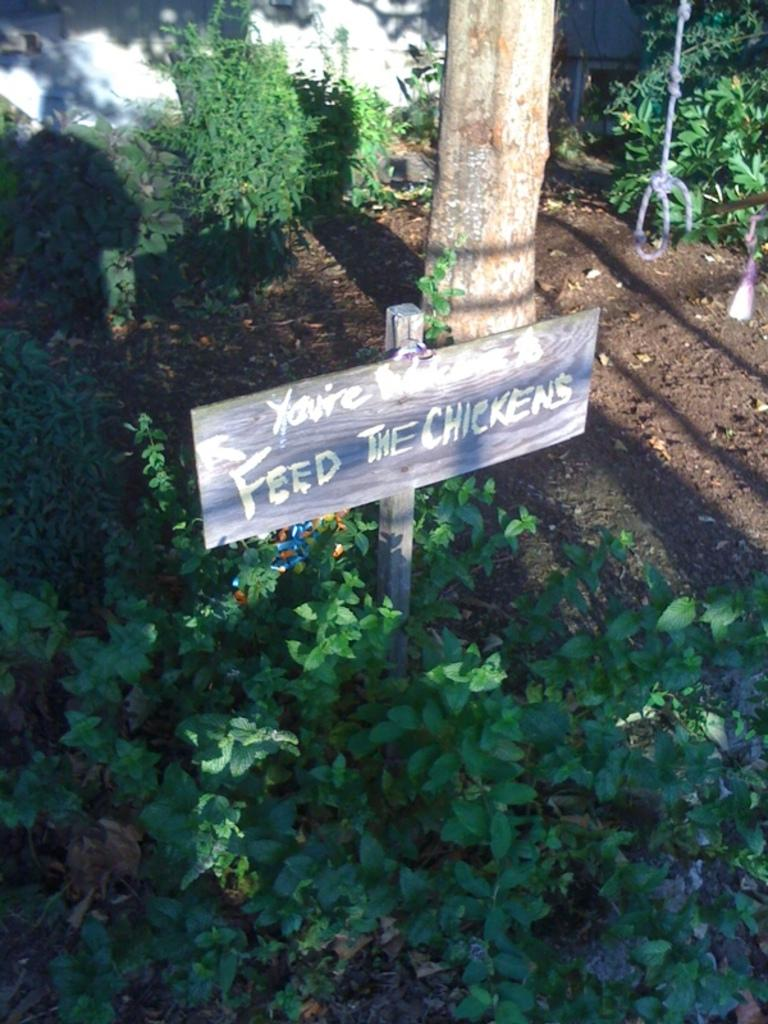What is the main object in the picture? There is a board in the picture. What is on the board? There is writing on the board. What can be seen around the board? There are plants around the board. What else can be seen in the background of the picture? There are other plants in the background of the picture. Can you tell me where the receipt is located in the picture? There is no receipt present in the image. What type of sofa can be seen in the picture? There is no sofa present in the image. 